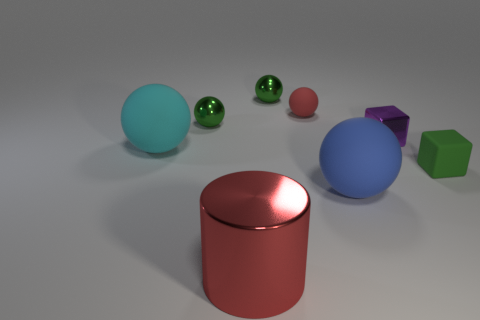Is the number of shiny things that are to the left of the tiny green matte object less than the number of big cyan matte spheres right of the tiny red ball?
Provide a succinct answer. No. What is the color of the object that is in front of the big blue thing?
Provide a succinct answer. Red. What number of other things are there of the same color as the metal block?
Ensure brevity in your answer.  0. Do the shiny thing that is in front of the blue matte object and the cyan rubber sphere have the same size?
Ensure brevity in your answer.  Yes. There is a large blue matte sphere; how many small matte things are to the right of it?
Your answer should be very brief. 1. Is there a metal cylinder of the same size as the purple shiny object?
Provide a short and direct response. No. Is the color of the metallic cylinder the same as the tiny shiny block?
Provide a succinct answer. No. There is a tiny matte object behind the green thing that is left of the big metal thing; what color is it?
Keep it short and to the point. Red. How many large objects are in front of the blue matte sphere and behind the large cylinder?
Keep it short and to the point. 0. What number of purple metal things have the same shape as the cyan thing?
Your answer should be compact. 0. 